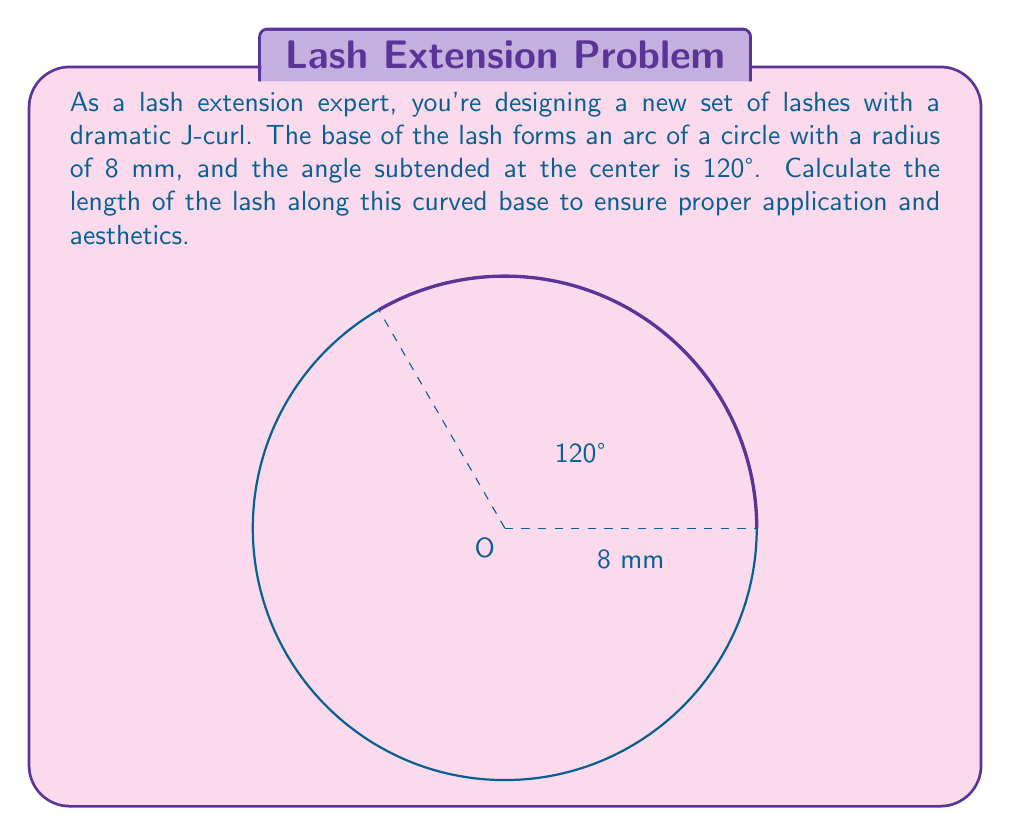Can you answer this question? To solve this problem, we'll use the formula for arc length:

$$ s = r\theta $$

Where:
$s$ is the arc length
$r$ is the radius of the circle
$\theta$ is the central angle in radians

Given:
- Radius $r = 8$ mm
- Central angle = 120°

Step 1: Convert the angle from degrees to radians
$$ \theta = 120° \times \frac{\pi}{180°} = \frac{2\pi}{3} \text{ radians} $$

Step 2: Apply the arc length formula
$$ s = r\theta = 8 \times \frac{2\pi}{3} = \frac{16\pi}{3} \text{ mm} $$

Step 3: Simplify and round to two decimal places
$$ s \approx 16.76 \text{ mm} $$
Answer: The length of the lash along the curved base is approximately 16.76 mm. 